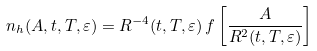Convert formula to latex. <formula><loc_0><loc_0><loc_500><loc_500>n _ { h } ( A , t , T , \varepsilon ) = R ^ { - 4 } ( t , T , \varepsilon ) \, f \left [ \frac { A } { R ^ { 2 } ( t , T , \varepsilon ) } \right ] \,</formula> 